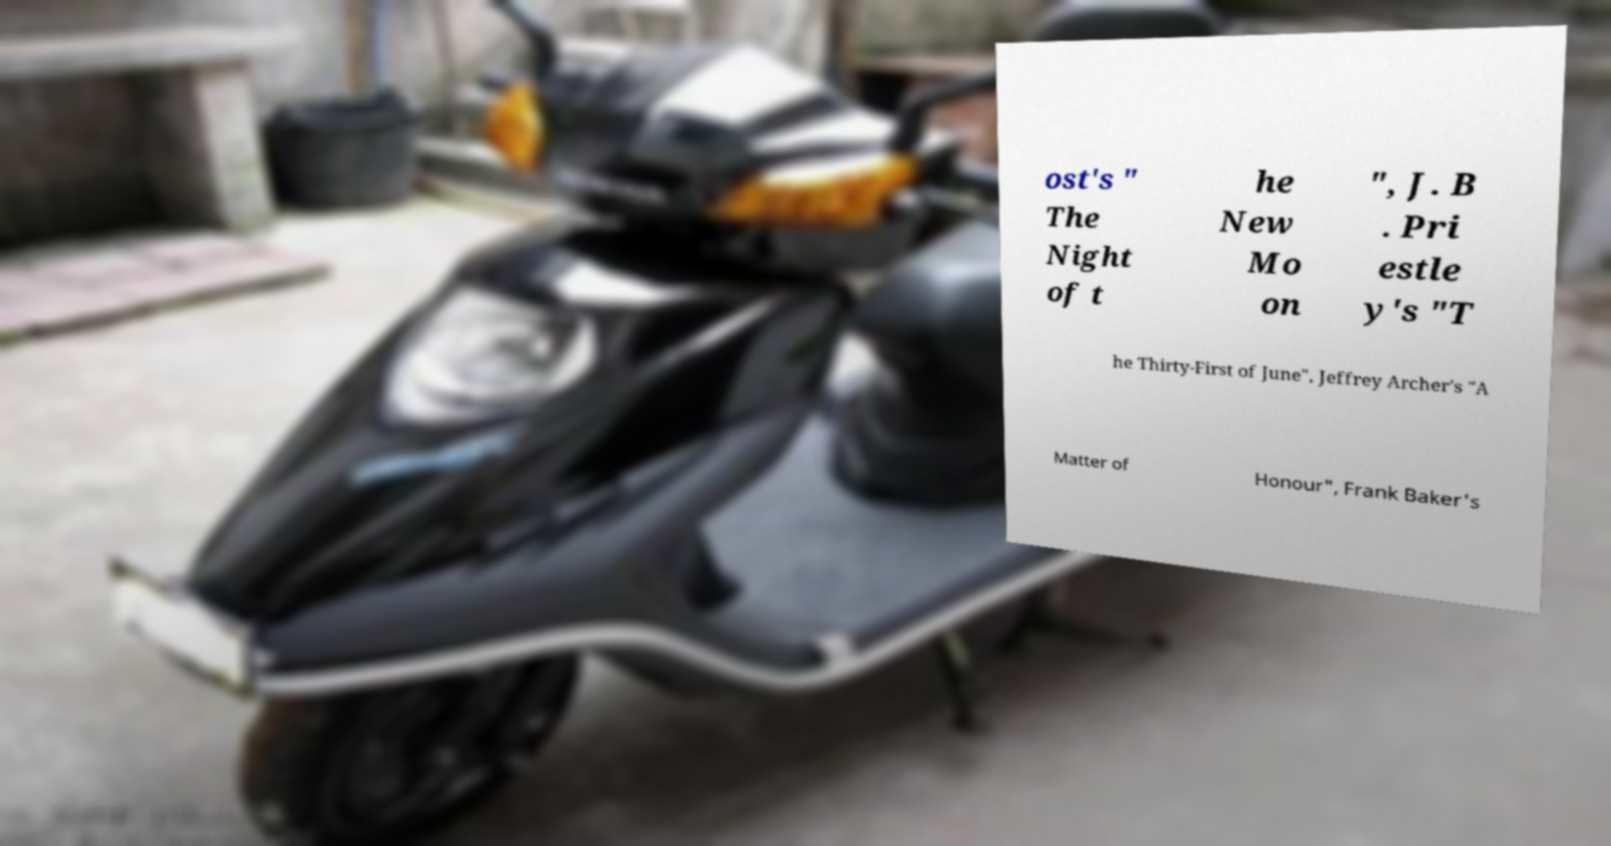Can you accurately transcribe the text from the provided image for me? ost's " The Night of t he New Mo on ", J. B . Pri estle y's "T he Thirty-First of June", Jeffrey Archer's "A Matter of Honour", Frank Baker's 